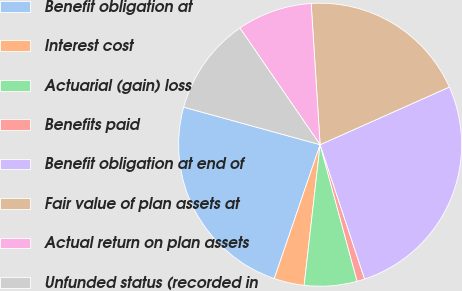Convert chart to OTSL. <chart><loc_0><loc_0><loc_500><loc_500><pie_chart><fcel>Benefit obligation at<fcel>Interest cost<fcel>Actuarial (gain) loss<fcel>Benefits paid<fcel>Benefit obligation at end of<fcel>Fair value of plan assets at<fcel>Actual return on plan assets<fcel>Unfunded status (recorded in<nl><fcel>24.03%<fcel>3.45%<fcel>6.01%<fcel>0.88%<fcel>26.59%<fcel>19.33%<fcel>8.58%<fcel>11.14%<nl></chart> 